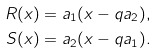Convert formula to latex. <formula><loc_0><loc_0><loc_500><loc_500>R ( x ) & = a _ { 1 } ( x - q a _ { 2 } ) , \\ S ( x ) & = a _ { 2 } ( x - q a _ { 1 } ) .</formula> 